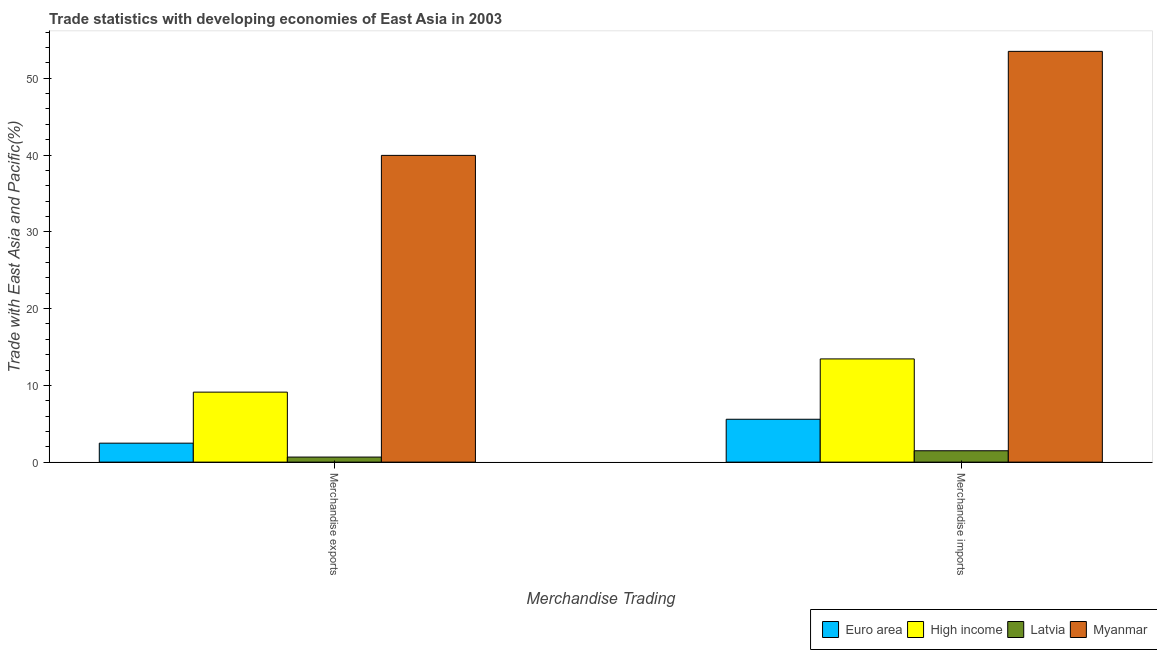How many different coloured bars are there?
Offer a very short reply. 4. How many groups of bars are there?
Provide a short and direct response. 2. Are the number of bars per tick equal to the number of legend labels?
Make the answer very short. Yes. How many bars are there on the 1st tick from the left?
Your answer should be very brief. 4. What is the label of the 1st group of bars from the left?
Your answer should be compact. Merchandise exports. What is the merchandise imports in Latvia?
Keep it short and to the point. 1.48. Across all countries, what is the maximum merchandise exports?
Make the answer very short. 39.96. Across all countries, what is the minimum merchandise exports?
Keep it short and to the point. 0.66. In which country was the merchandise exports maximum?
Offer a very short reply. Myanmar. In which country was the merchandise exports minimum?
Your answer should be compact. Latvia. What is the total merchandise imports in the graph?
Your answer should be very brief. 74.02. What is the difference between the merchandise imports in High income and that in Myanmar?
Offer a very short reply. -40.06. What is the difference between the merchandise imports in Euro area and the merchandise exports in High income?
Offer a very short reply. -3.53. What is the average merchandise imports per country?
Offer a terse response. 18.5. What is the difference between the merchandise exports and merchandise imports in Myanmar?
Provide a short and direct response. -13.55. What is the ratio of the merchandise imports in Latvia to that in Euro area?
Make the answer very short. 0.27. In how many countries, is the merchandise exports greater than the average merchandise exports taken over all countries?
Provide a succinct answer. 1. What does the 4th bar from the left in Merchandise exports represents?
Give a very brief answer. Myanmar. What does the 2nd bar from the right in Merchandise exports represents?
Your answer should be compact. Latvia. How many bars are there?
Your answer should be compact. 8. Does the graph contain grids?
Offer a terse response. No. Where does the legend appear in the graph?
Provide a short and direct response. Bottom right. How are the legend labels stacked?
Offer a very short reply. Horizontal. What is the title of the graph?
Your response must be concise. Trade statistics with developing economies of East Asia in 2003. What is the label or title of the X-axis?
Keep it short and to the point. Merchandise Trading. What is the label or title of the Y-axis?
Keep it short and to the point. Trade with East Asia and Pacific(%). What is the Trade with East Asia and Pacific(%) of Euro area in Merchandise exports?
Your response must be concise. 2.47. What is the Trade with East Asia and Pacific(%) of High income in Merchandise exports?
Your response must be concise. 9.12. What is the Trade with East Asia and Pacific(%) in Latvia in Merchandise exports?
Your answer should be very brief. 0.66. What is the Trade with East Asia and Pacific(%) of Myanmar in Merchandise exports?
Your answer should be compact. 39.96. What is the Trade with East Asia and Pacific(%) in Euro area in Merchandise imports?
Provide a succinct answer. 5.58. What is the Trade with East Asia and Pacific(%) in High income in Merchandise imports?
Provide a succinct answer. 13.45. What is the Trade with East Asia and Pacific(%) of Latvia in Merchandise imports?
Your answer should be very brief. 1.48. What is the Trade with East Asia and Pacific(%) of Myanmar in Merchandise imports?
Offer a terse response. 53.51. Across all Merchandise Trading, what is the maximum Trade with East Asia and Pacific(%) in Euro area?
Offer a very short reply. 5.58. Across all Merchandise Trading, what is the maximum Trade with East Asia and Pacific(%) in High income?
Provide a succinct answer. 13.45. Across all Merchandise Trading, what is the maximum Trade with East Asia and Pacific(%) in Latvia?
Give a very brief answer. 1.48. Across all Merchandise Trading, what is the maximum Trade with East Asia and Pacific(%) of Myanmar?
Offer a very short reply. 53.51. Across all Merchandise Trading, what is the minimum Trade with East Asia and Pacific(%) of Euro area?
Provide a succinct answer. 2.47. Across all Merchandise Trading, what is the minimum Trade with East Asia and Pacific(%) of High income?
Make the answer very short. 9.12. Across all Merchandise Trading, what is the minimum Trade with East Asia and Pacific(%) in Latvia?
Provide a succinct answer. 0.66. Across all Merchandise Trading, what is the minimum Trade with East Asia and Pacific(%) of Myanmar?
Keep it short and to the point. 39.96. What is the total Trade with East Asia and Pacific(%) in Euro area in the graph?
Your answer should be very brief. 8.05. What is the total Trade with East Asia and Pacific(%) in High income in the graph?
Ensure brevity in your answer.  22.56. What is the total Trade with East Asia and Pacific(%) of Latvia in the graph?
Provide a short and direct response. 2.14. What is the total Trade with East Asia and Pacific(%) in Myanmar in the graph?
Keep it short and to the point. 93.47. What is the difference between the Trade with East Asia and Pacific(%) in Euro area in Merchandise exports and that in Merchandise imports?
Give a very brief answer. -3.11. What is the difference between the Trade with East Asia and Pacific(%) of High income in Merchandise exports and that in Merchandise imports?
Provide a short and direct response. -4.33. What is the difference between the Trade with East Asia and Pacific(%) of Latvia in Merchandise exports and that in Merchandise imports?
Your answer should be compact. -0.82. What is the difference between the Trade with East Asia and Pacific(%) in Myanmar in Merchandise exports and that in Merchandise imports?
Offer a very short reply. -13.55. What is the difference between the Trade with East Asia and Pacific(%) in Euro area in Merchandise exports and the Trade with East Asia and Pacific(%) in High income in Merchandise imports?
Provide a succinct answer. -10.97. What is the difference between the Trade with East Asia and Pacific(%) in Euro area in Merchandise exports and the Trade with East Asia and Pacific(%) in Latvia in Merchandise imports?
Ensure brevity in your answer.  0.99. What is the difference between the Trade with East Asia and Pacific(%) of Euro area in Merchandise exports and the Trade with East Asia and Pacific(%) of Myanmar in Merchandise imports?
Keep it short and to the point. -51.04. What is the difference between the Trade with East Asia and Pacific(%) in High income in Merchandise exports and the Trade with East Asia and Pacific(%) in Latvia in Merchandise imports?
Give a very brief answer. 7.64. What is the difference between the Trade with East Asia and Pacific(%) of High income in Merchandise exports and the Trade with East Asia and Pacific(%) of Myanmar in Merchandise imports?
Offer a very short reply. -44.39. What is the difference between the Trade with East Asia and Pacific(%) in Latvia in Merchandise exports and the Trade with East Asia and Pacific(%) in Myanmar in Merchandise imports?
Your response must be concise. -52.85. What is the average Trade with East Asia and Pacific(%) in Euro area per Merchandise Trading?
Your answer should be compact. 4.03. What is the average Trade with East Asia and Pacific(%) in High income per Merchandise Trading?
Make the answer very short. 11.28. What is the average Trade with East Asia and Pacific(%) of Latvia per Merchandise Trading?
Ensure brevity in your answer.  1.07. What is the average Trade with East Asia and Pacific(%) of Myanmar per Merchandise Trading?
Ensure brevity in your answer.  46.73. What is the difference between the Trade with East Asia and Pacific(%) of Euro area and Trade with East Asia and Pacific(%) of High income in Merchandise exports?
Your answer should be very brief. -6.65. What is the difference between the Trade with East Asia and Pacific(%) in Euro area and Trade with East Asia and Pacific(%) in Latvia in Merchandise exports?
Give a very brief answer. 1.81. What is the difference between the Trade with East Asia and Pacific(%) in Euro area and Trade with East Asia and Pacific(%) in Myanmar in Merchandise exports?
Give a very brief answer. -37.49. What is the difference between the Trade with East Asia and Pacific(%) in High income and Trade with East Asia and Pacific(%) in Latvia in Merchandise exports?
Keep it short and to the point. 8.46. What is the difference between the Trade with East Asia and Pacific(%) in High income and Trade with East Asia and Pacific(%) in Myanmar in Merchandise exports?
Make the answer very short. -30.84. What is the difference between the Trade with East Asia and Pacific(%) in Latvia and Trade with East Asia and Pacific(%) in Myanmar in Merchandise exports?
Offer a very short reply. -39.3. What is the difference between the Trade with East Asia and Pacific(%) in Euro area and Trade with East Asia and Pacific(%) in High income in Merchandise imports?
Ensure brevity in your answer.  -7.86. What is the difference between the Trade with East Asia and Pacific(%) in Euro area and Trade with East Asia and Pacific(%) in Latvia in Merchandise imports?
Provide a short and direct response. 4.1. What is the difference between the Trade with East Asia and Pacific(%) of Euro area and Trade with East Asia and Pacific(%) of Myanmar in Merchandise imports?
Provide a short and direct response. -47.92. What is the difference between the Trade with East Asia and Pacific(%) in High income and Trade with East Asia and Pacific(%) in Latvia in Merchandise imports?
Provide a succinct answer. 11.96. What is the difference between the Trade with East Asia and Pacific(%) of High income and Trade with East Asia and Pacific(%) of Myanmar in Merchandise imports?
Keep it short and to the point. -40.06. What is the difference between the Trade with East Asia and Pacific(%) in Latvia and Trade with East Asia and Pacific(%) in Myanmar in Merchandise imports?
Offer a very short reply. -52.03. What is the ratio of the Trade with East Asia and Pacific(%) in Euro area in Merchandise exports to that in Merchandise imports?
Your answer should be very brief. 0.44. What is the ratio of the Trade with East Asia and Pacific(%) in High income in Merchandise exports to that in Merchandise imports?
Make the answer very short. 0.68. What is the ratio of the Trade with East Asia and Pacific(%) of Latvia in Merchandise exports to that in Merchandise imports?
Offer a very short reply. 0.45. What is the ratio of the Trade with East Asia and Pacific(%) in Myanmar in Merchandise exports to that in Merchandise imports?
Ensure brevity in your answer.  0.75. What is the difference between the highest and the second highest Trade with East Asia and Pacific(%) of Euro area?
Offer a terse response. 3.11. What is the difference between the highest and the second highest Trade with East Asia and Pacific(%) in High income?
Provide a short and direct response. 4.33. What is the difference between the highest and the second highest Trade with East Asia and Pacific(%) of Latvia?
Your response must be concise. 0.82. What is the difference between the highest and the second highest Trade with East Asia and Pacific(%) in Myanmar?
Your response must be concise. 13.55. What is the difference between the highest and the lowest Trade with East Asia and Pacific(%) of Euro area?
Offer a very short reply. 3.11. What is the difference between the highest and the lowest Trade with East Asia and Pacific(%) of High income?
Your answer should be compact. 4.33. What is the difference between the highest and the lowest Trade with East Asia and Pacific(%) of Latvia?
Your answer should be very brief. 0.82. What is the difference between the highest and the lowest Trade with East Asia and Pacific(%) of Myanmar?
Ensure brevity in your answer.  13.55. 